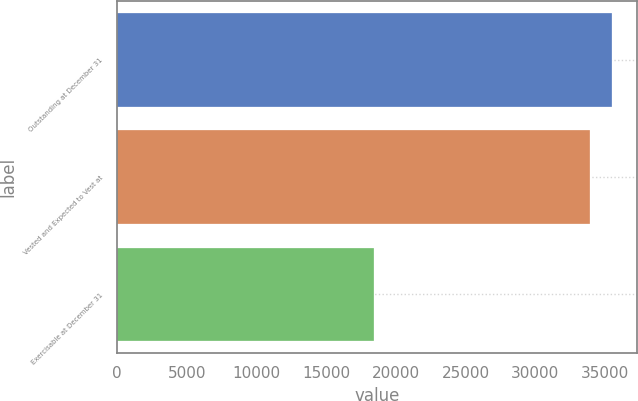<chart> <loc_0><loc_0><loc_500><loc_500><bar_chart><fcel>Outstanding at December 31<fcel>Vested and Expected to Vest at<fcel>Exercisable at December 31<nl><fcel>35525.4<fcel>33887<fcel>18436<nl></chart> 